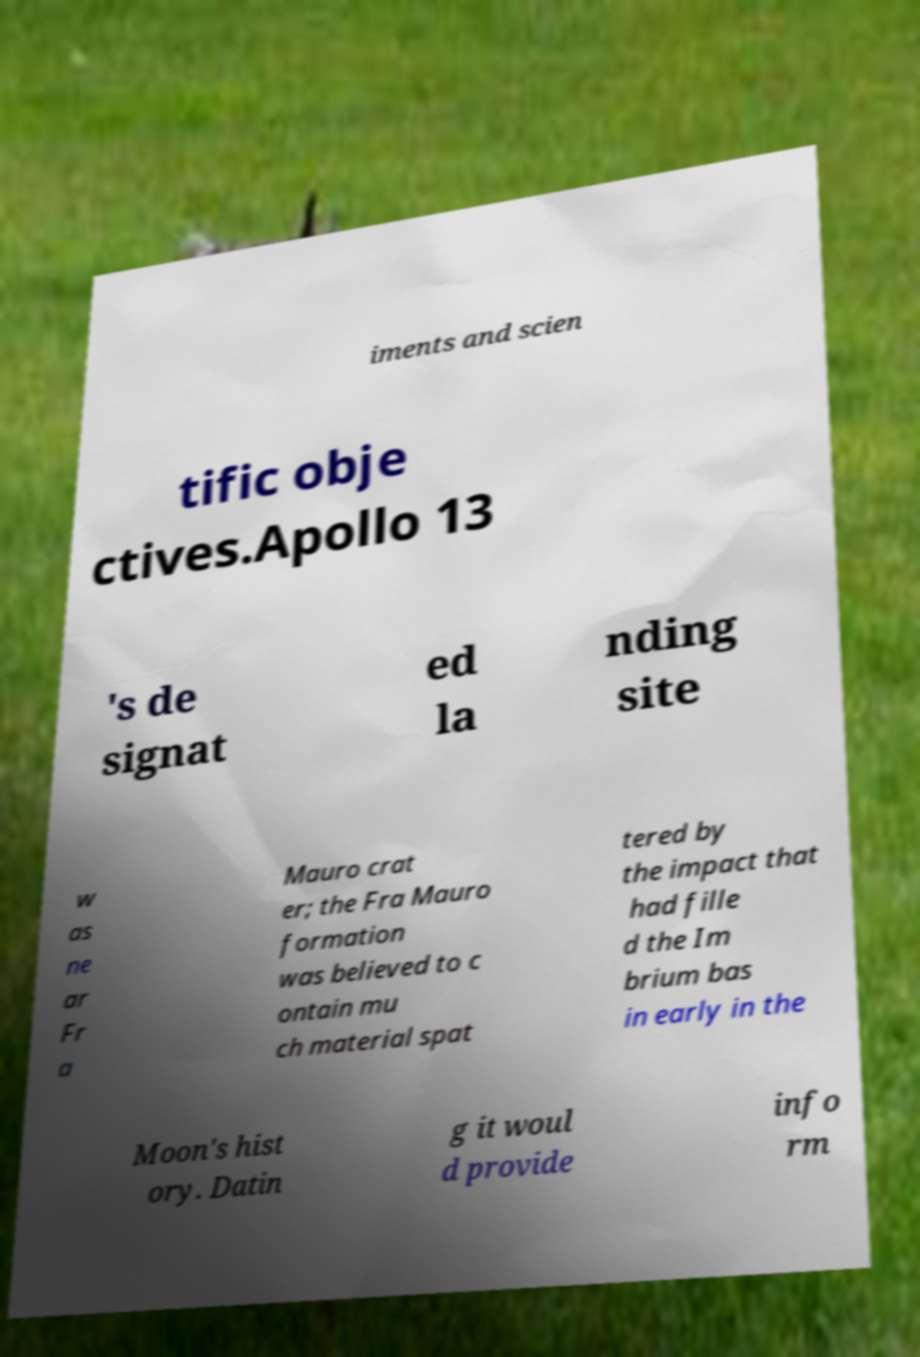Could you assist in decoding the text presented in this image and type it out clearly? iments and scien tific obje ctives.Apollo 13 's de signat ed la nding site w as ne ar Fr a Mauro crat er; the Fra Mauro formation was believed to c ontain mu ch material spat tered by the impact that had fille d the Im brium bas in early in the Moon's hist ory. Datin g it woul d provide info rm 